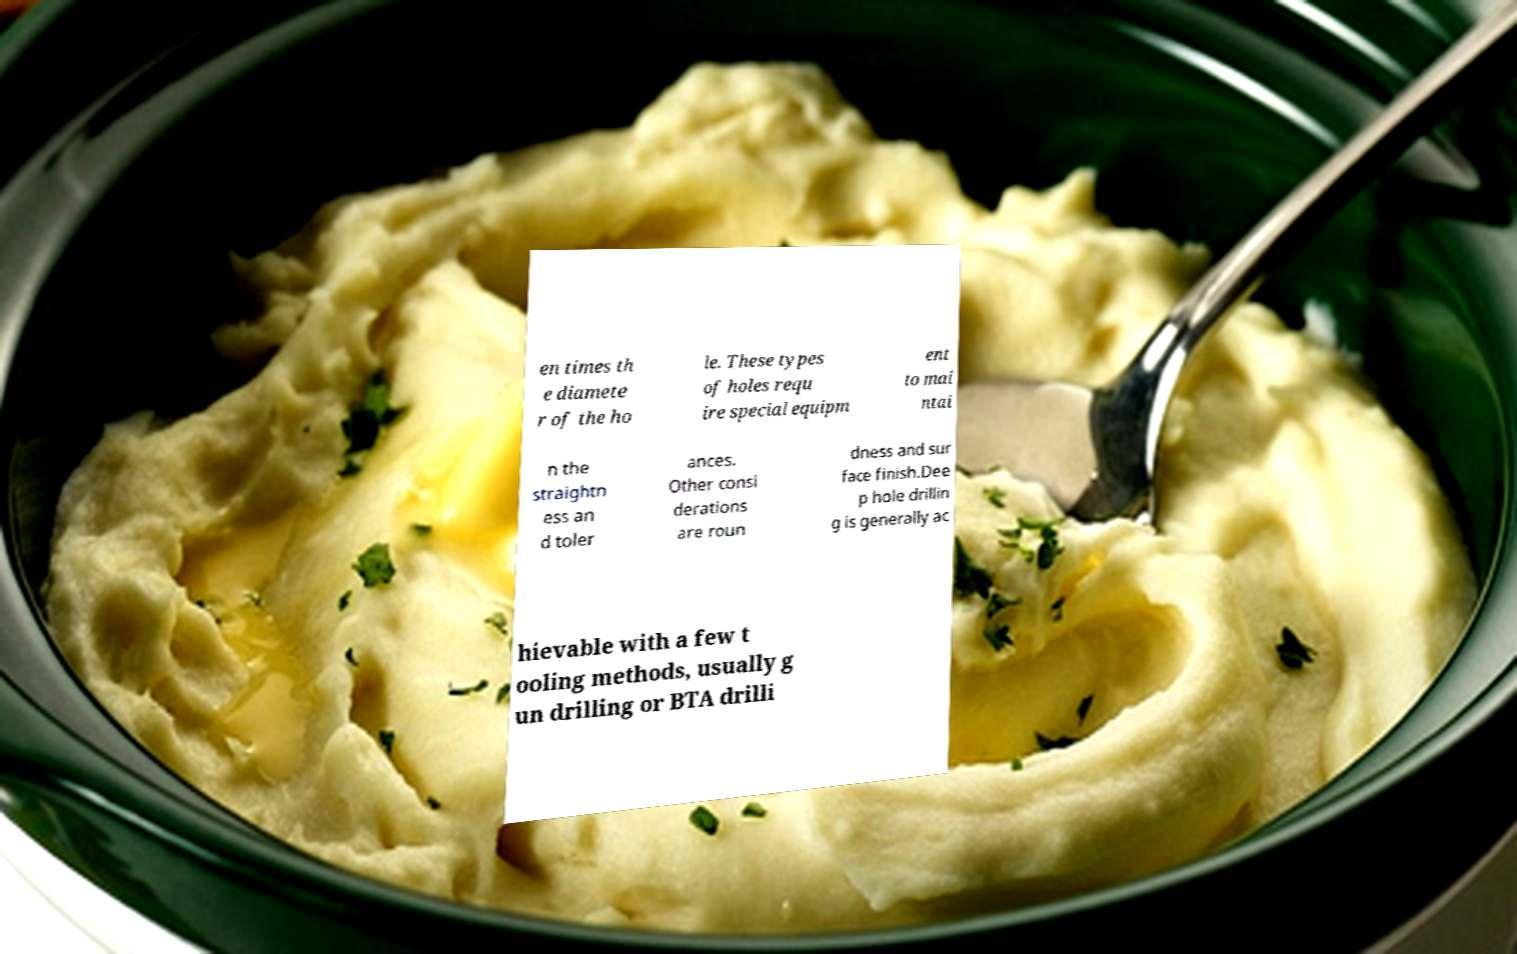Could you assist in decoding the text presented in this image and type it out clearly? en times th e diamete r of the ho le. These types of holes requ ire special equipm ent to mai ntai n the straightn ess an d toler ances. Other consi derations are roun dness and sur face finish.Dee p hole drillin g is generally ac hievable with a few t ooling methods, usually g un drilling or BTA drilli 